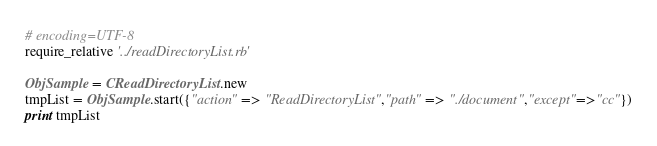Convert code to text. <code><loc_0><loc_0><loc_500><loc_500><_Ruby_># encoding=UTF-8
require_relative '../readDirectoryList.rb'

ObjSample = CReadDirectoryList.new
tmpList = ObjSample.start({"action" => "ReadDirectoryList","path" => "./document","except"=>"cc"})
print tmpList</code> 